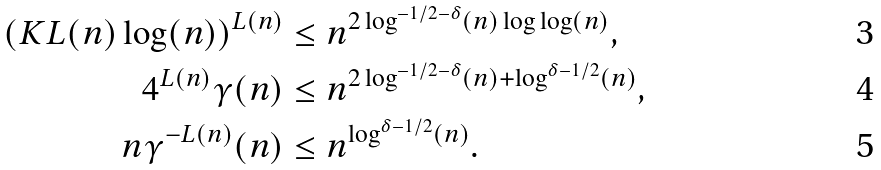<formula> <loc_0><loc_0><loc_500><loc_500>\left ( K L ( n ) \log ( n ) \right ) ^ { L ( n ) } & \leq n ^ { 2 \log ^ { - 1 / 2 - \delta } ( n ) \log \log ( n ) } , \\ 4 ^ { L ( n ) } \gamma ( n ) & \leq n ^ { 2 \log ^ { - 1 / 2 - \delta } ( n ) + \log ^ { \delta - 1 / 2 } ( n ) } , \\ n \gamma ^ { - L ( n ) } ( n ) & \leq n ^ { \log ^ { \delta - 1 / 2 } ( n ) } .</formula> 